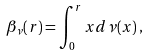Convert formula to latex. <formula><loc_0><loc_0><loc_500><loc_500>\beta _ { \nu } ( r ) = \int _ { 0 } ^ { r } x d \nu ( x ) \, ,</formula> 